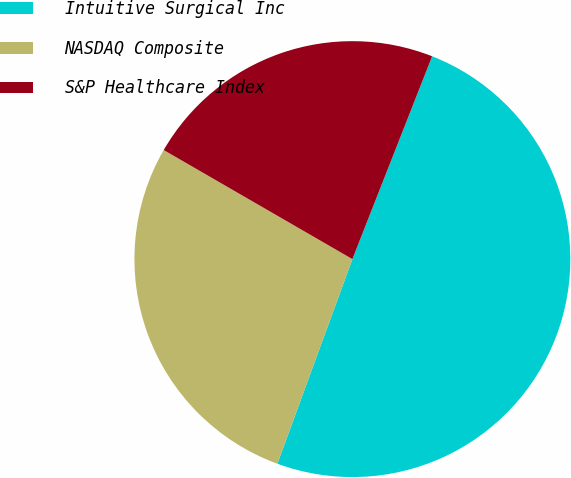Convert chart to OTSL. <chart><loc_0><loc_0><loc_500><loc_500><pie_chart><fcel>Intuitive Surgical Inc<fcel>NASDAQ Composite<fcel>S&P Healthcare Index<nl><fcel>49.63%<fcel>27.75%<fcel>22.62%<nl></chart> 